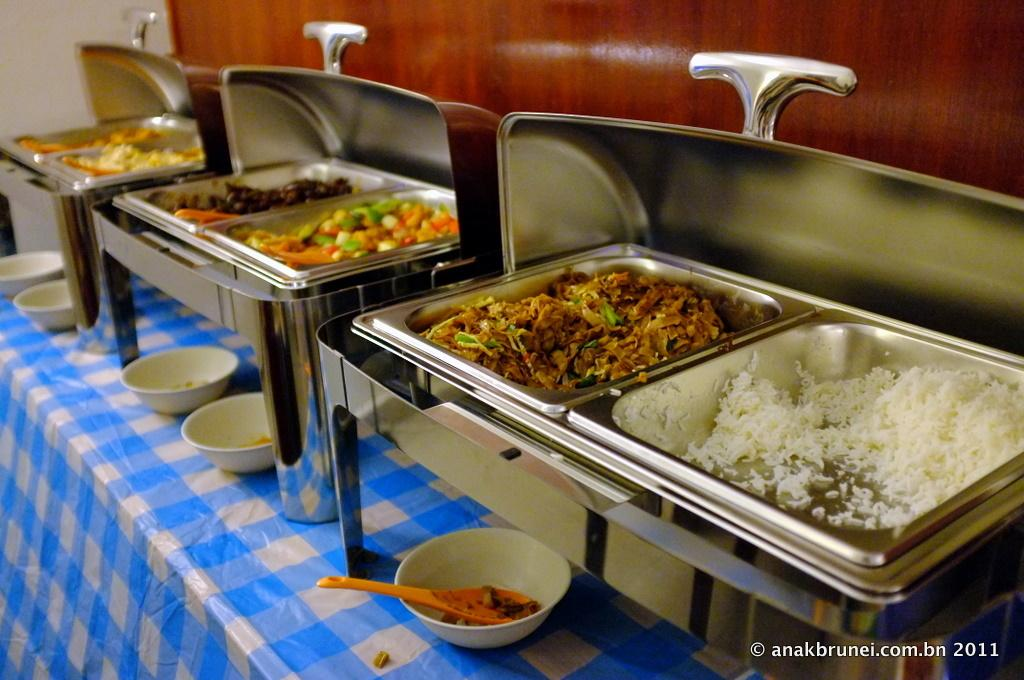What type of items can be seen in the image? There are eatables in the image. How are the eatables arranged or presented? The eatables are placed in utensils. What is used to catch any spills or drips from the utensils? There are bowls placed below the utensils. Can you see any deer in the scene depicted in the image? There is no scene or deer present in the image; it only shows eatables placed in utensils with bowls below. 